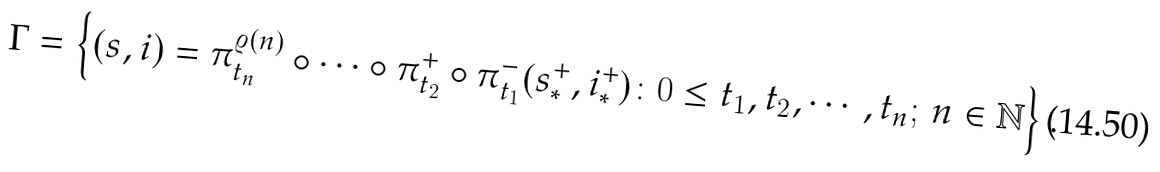Convert formula to latex. <formula><loc_0><loc_0><loc_500><loc_500>\Gamma = \left \{ ( s , i ) = \pi _ { t _ { n } } ^ { \varrho ( n ) } \circ \cdots \circ \pi _ { t _ { 2 } } ^ { + } \circ \pi _ { t _ { 1 } } ^ { - } ( s ^ { + } _ { * } , i ^ { + } _ { * } ) \colon 0 \leq t _ { 1 } , t _ { 2 } , \cdots , t _ { n } ; \, n \in \mathbb { N } \right \} .</formula> 